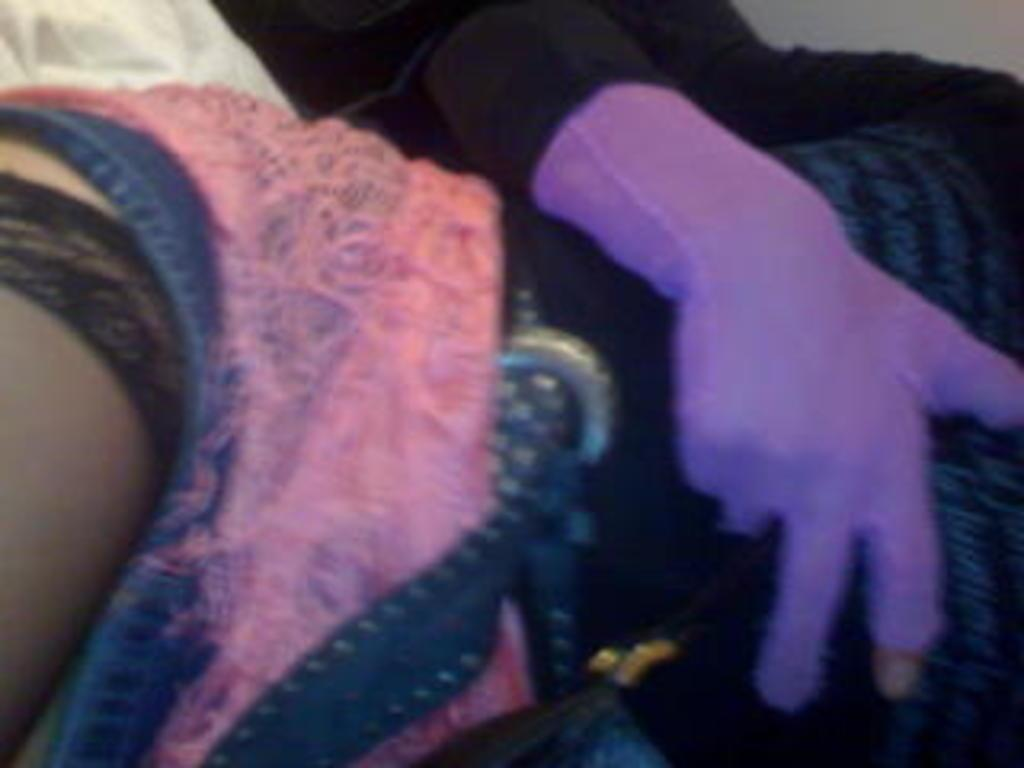What is the main subject of the image? There is a person in the image. What is the person doing in the image? The person is laying down. What colors can be seen in the person's outfit? The person is wearing a black and pink color dress and purple color gloves. What type of hill can be seen in the background of the image? There is no hill present in the image; it only features a person laying down. What tasks is the servant performing in the image? There is no servant present in the image, nor are there any tasks being performed. 